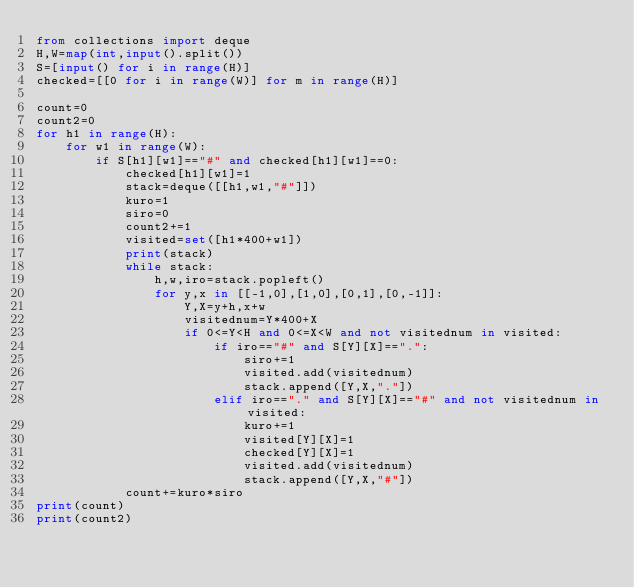Convert code to text. <code><loc_0><loc_0><loc_500><loc_500><_Python_>from collections import deque
H,W=map(int,input().split())
S=[input() for i in range(H)]
checked=[[0 for i in range(W)] for m in range(H)]

count=0
count2=0
for h1 in range(H):
    for w1 in range(W):
        if S[h1][w1]=="#" and checked[h1][w1]==0:
            checked[h1][w1]=1
            stack=deque([[h1,w1,"#"]])
            kuro=1
            siro=0
            count2+=1
            visited=set([h1*400+w1])
            print(stack)
            while stack:
                h,w,iro=stack.popleft()
                for y,x in [[-1,0],[1,0],[0,1],[0,-1]]:
                    Y,X=y+h,x+w
                    visitednum=Y*400+X
                    if 0<=Y<H and 0<=X<W and not visitednum in visited:
                        if iro=="#" and S[Y][X]==".":
                            siro+=1
                            visited.add(visitednum)
                            stack.append([Y,X,"."])
                        elif iro=="." and S[Y][X]=="#" and not visitednum in visited:
                            kuro+=1
                            visited[Y][X]=1
                            checked[Y][X]=1
                            visited.add(visitednum)
                            stack.append([Y,X,"#"])
            count+=kuro*siro
print(count)
print(count2)
</code> 